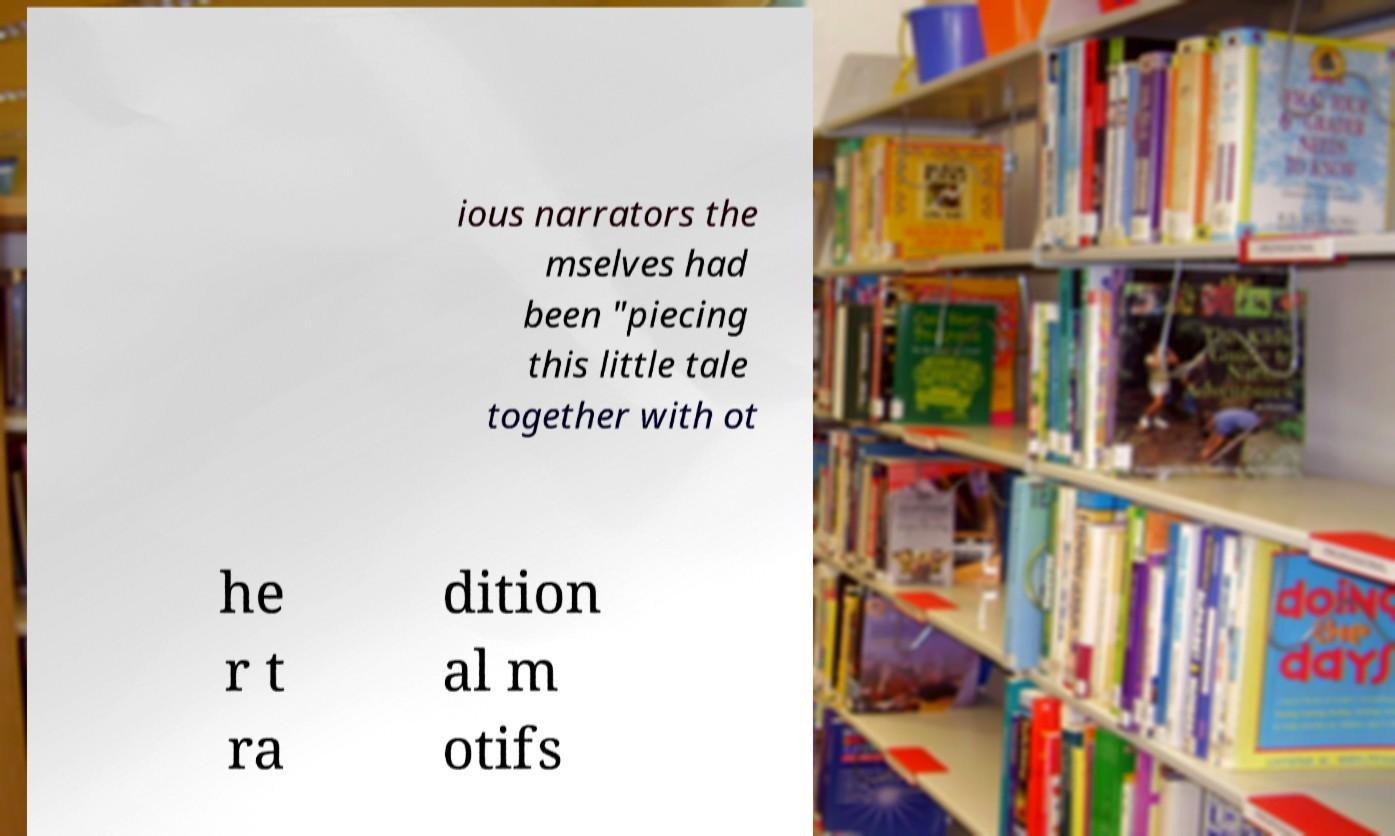For documentation purposes, I need the text within this image transcribed. Could you provide that? ious narrators the mselves had been "piecing this little tale together with ot he r t ra dition al m otifs 